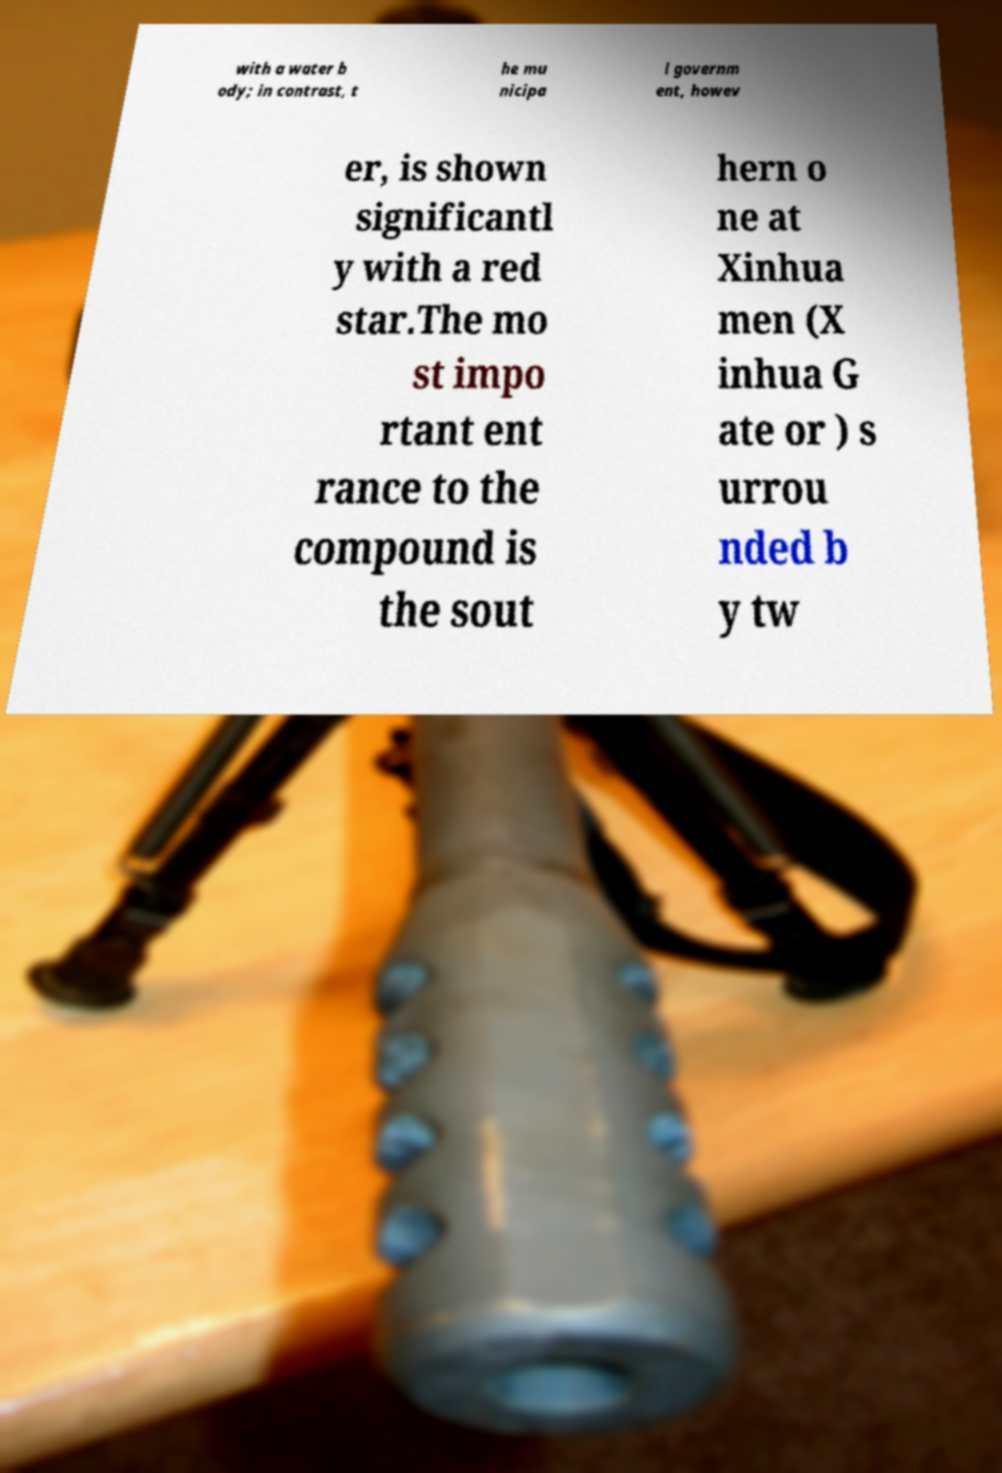Could you extract and type out the text from this image? with a water b ody; in contrast, t he mu nicipa l governm ent, howev er, is shown significantl y with a red star.The mo st impo rtant ent rance to the compound is the sout hern o ne at Xinhua men (X inhua G ate or ) s urrou nded b y tw 